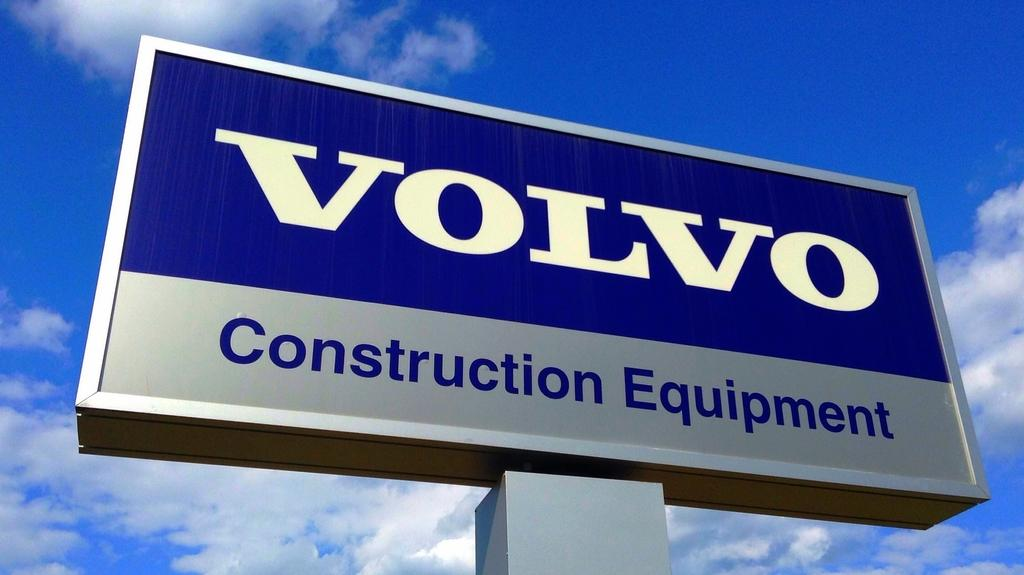<image>
Relay a brief, clear account of the picture shown. The Volvo sign sit high in the sky with clouds behind it. 